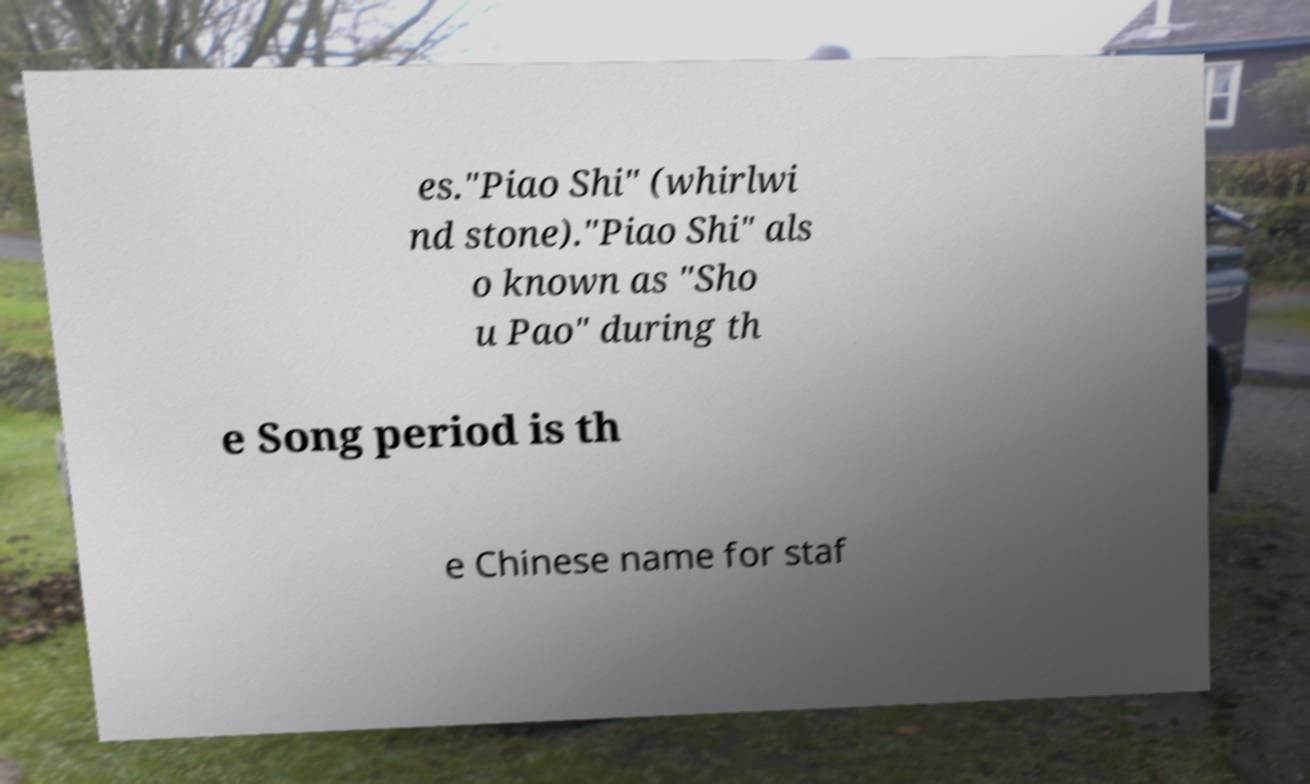What messages or text are displayed in this image? I need them in a readable, typed format. es."Piao Shi" (whirlwi nd stone)."Piao Shi" als o known as "Sho u Pao" during th e Song period is th e Chinese name for staf 